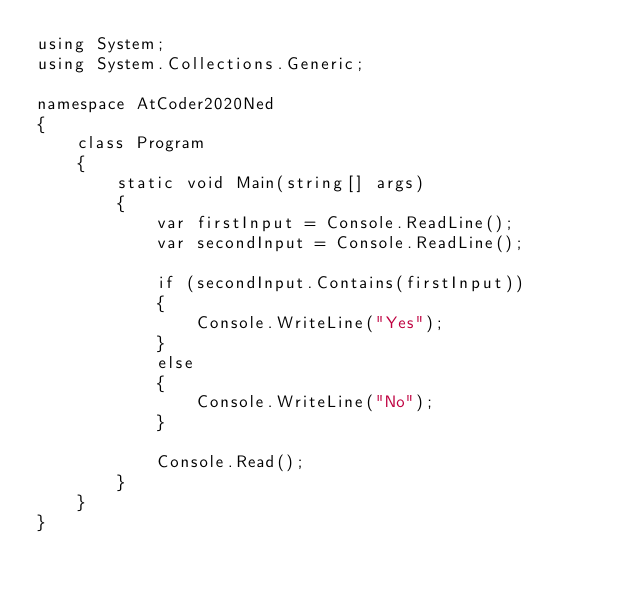<code> <loc_0><loc_0><loc_500><loc_500><_C#_>using System;
using System.Collections.Generic;

namespace AtCoder2020Ned
{
    class Program
    {
        static void Main(string[] args)
        {
            var firstInput = Console.ReadLine();
            var secondInput = Console.ReadLine();

            if (secondInput.Contains(firstInput))
            {
                Console.WriteLine("Yes");
            }
            else
            {
                Console.WriteLine("No");
            }

            Console.Read();
        }
    }
}
</code> 